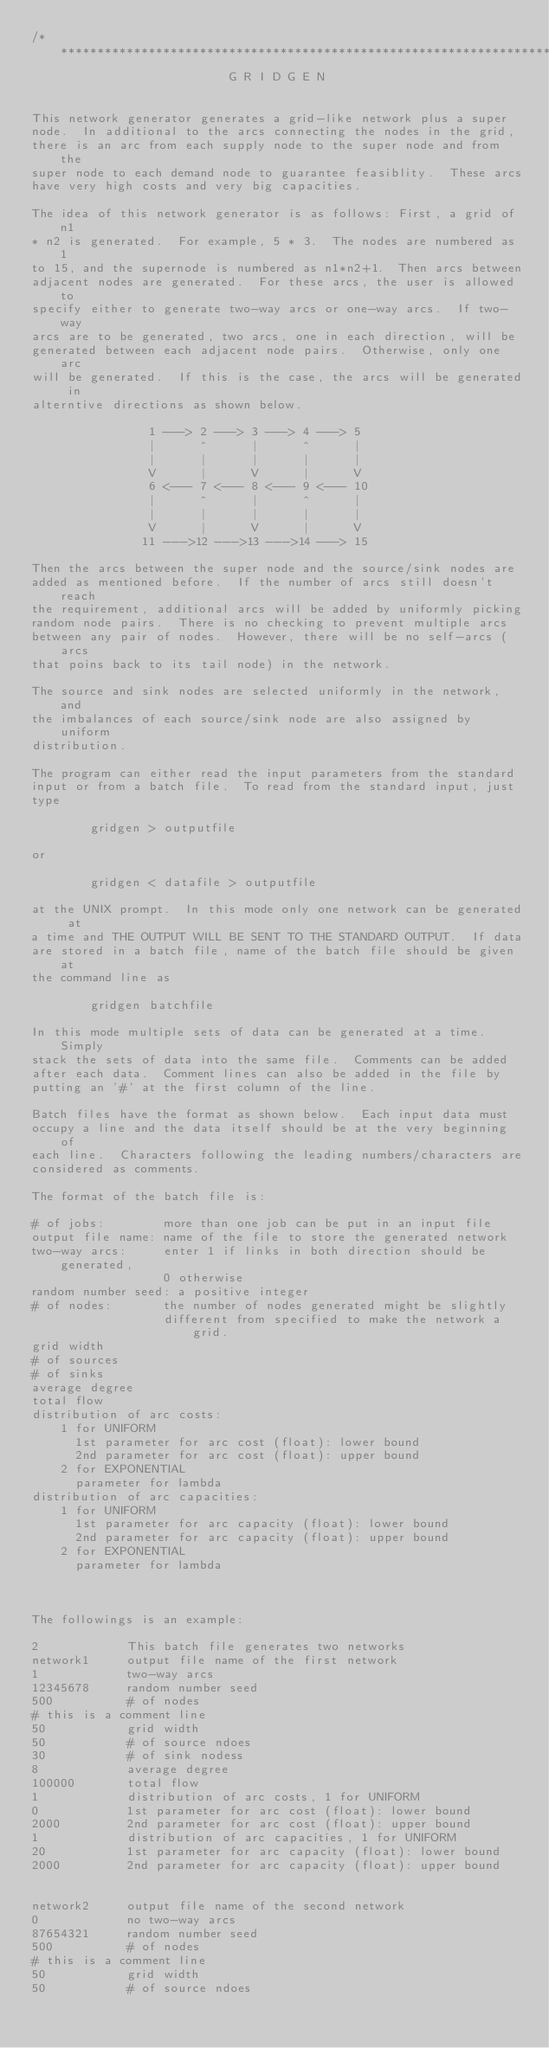<code> <loc_0><loc_0><loc_500><loc_500><_C_>/********************************************************************
                           G R I D G E N


This network generator generates a grid-like network plus a super
node.  In additional to the arcs connecting the nodes in the grid,
there is an arc from each supply node to the super node and from the
super node to each demand node to guarantee feasiblity.  These arcs
have very high costs and very big capacities.

The idea of this network generator is as follows: First, a grid of n1
* n2 is generated.  For example, 5 * 3.  The nodes are numbered as 1
to 15, and the supernode is numbered as n1*n2+1.  Then arcs between
adjacent nodes are generated.  For these arcs, the user is allowed to
specify either to generate two-way arcs or one-way arcs.  If two-way
arcs are to be generated, two arcs, one in each direction, will be
generated between each adjacent node pairs.  Otherwise, only one arc
will be generated.  If this is the case, the arcs will be generated in
alterntive directions as shown below.

                1 ---> 2 ---> 3 ---> 4 ---> 5
                |      ^      |      ^      |
                |      |      |      |      |
                V      |      V      |      V
                6 <--- 7 <--- 8 <--- 9 <--- 10
                |      ^      |      ^      |
                |      |      |      |      |
                V      |      V      |      V
               11 --->12 --->13 --->14 ---> 15

Then the arcs between the super node and the source/sink nodes are
added as mentioned before.  If the number of arcs still doesn't reach
the requirement, additional arcs will be added by uniformly picking
random node pairs.  There is no checking to prevent multiple arcs
between any pair of nodes.  However, there will be no self-arcs (arcs
that poins back to its tail node) in the network.

The source and sink nodes are selected uniformly in the network, and
the imbalances of each source/sink node are also assigned by uniform
distribution.

The program can either read the input parameters from the standard
input or from a batch file.  To read from the standard input, just
type

        gridgen > outputfile

or

        gridgen < datafile > outputfile

at the UNIX prompt.  In this mode only one network can be generated at
a time and THE OUTPUT WILL BE SENT TO THE STANDARD OUTPUT.  If data
are stored in a batch file, name of the batch file should be given at
the command line as

        gridgen batchfile

In this mode multiple sets of data can be generated at a time.  Simply
stack the sets of data into the same file.  Comments can be added
after each data.  Comment lines can also be added in the file by
putting an '#' at the first column of the line.

Batch files have the format as shown below.  Each input data must
occupy a line and the data itself should be at the very beginning of
each line.  Characters following the leading numbers/characters are
considered as comments.

The format of the batch file is:

# of jobs:        more than one job can be put in an input file
output file name: name of the file to store the generated network
two-way arcs:     enter 1 if links in both direction should be generated,
                  0 otherwise
random number seed: a positive integer
# of nodes:       the number of nodes generated might be slightly
                  different from specified to make the network a grid.
grid width
# of sources
# of sinks
average degree
total flow
distribution of arc costs:
    1 for UNIFORM
      1st parameter for arc cost (float): lower bound
      2nd parameter for arc cost (float): upper bound
    2 for EXPONENTIAL
      parameter for lambda
distribution of arc capacities:
    1 for UNIFORM
      1st parameter for arc capacity (float): lower bound
      2nd parameter for arc capacity (float): upper bound
    2 for EXPONENTIAL
      parameter for lambda



The followings is an example:

2            This batch file generates two networks
network1     output file name of the first network
1            two-way arcs
12345678     random number seed
500          # of nodes
# this is a comment line
50           grid width
50           # of source ndoes
30           # of sink nodess
8            average degree
100000       total flow
1            distribution of arc costs, 1 for UNIFORM
0            1st parameter for arc cost (float): lower bound
2000         2nd parameter for arc cost (float): upper bound
1            distribution of arc capacities, 1 for UNIFORM
20           1st parameter for arc capacity (float): lower bound
2000         2nd parameter for arc capacity (float): upper bound


network2     output file name of the second network
0            no two-way arcs
87654321     random number seed
500          # of nodes
# this is a comment line
50           grid width
50           # of source ndoes</code> 